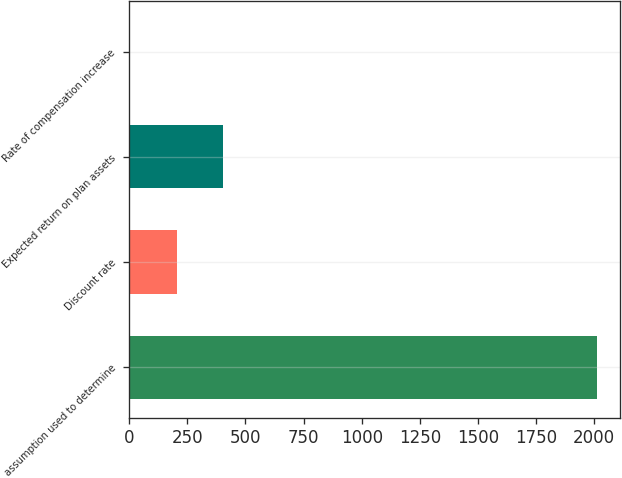Convert chart. <chart><loc_0><loc_0><loc_500><loc_500><bar_chart><fcel>assumption used to determine<fcel>Discount rate<fcel>Expected return on plan assets<fcel>Rate of compensation increase<nl><fcel>2011<fcel>203.49<fcel>404.32<fcel>2.66<nl></chart> 